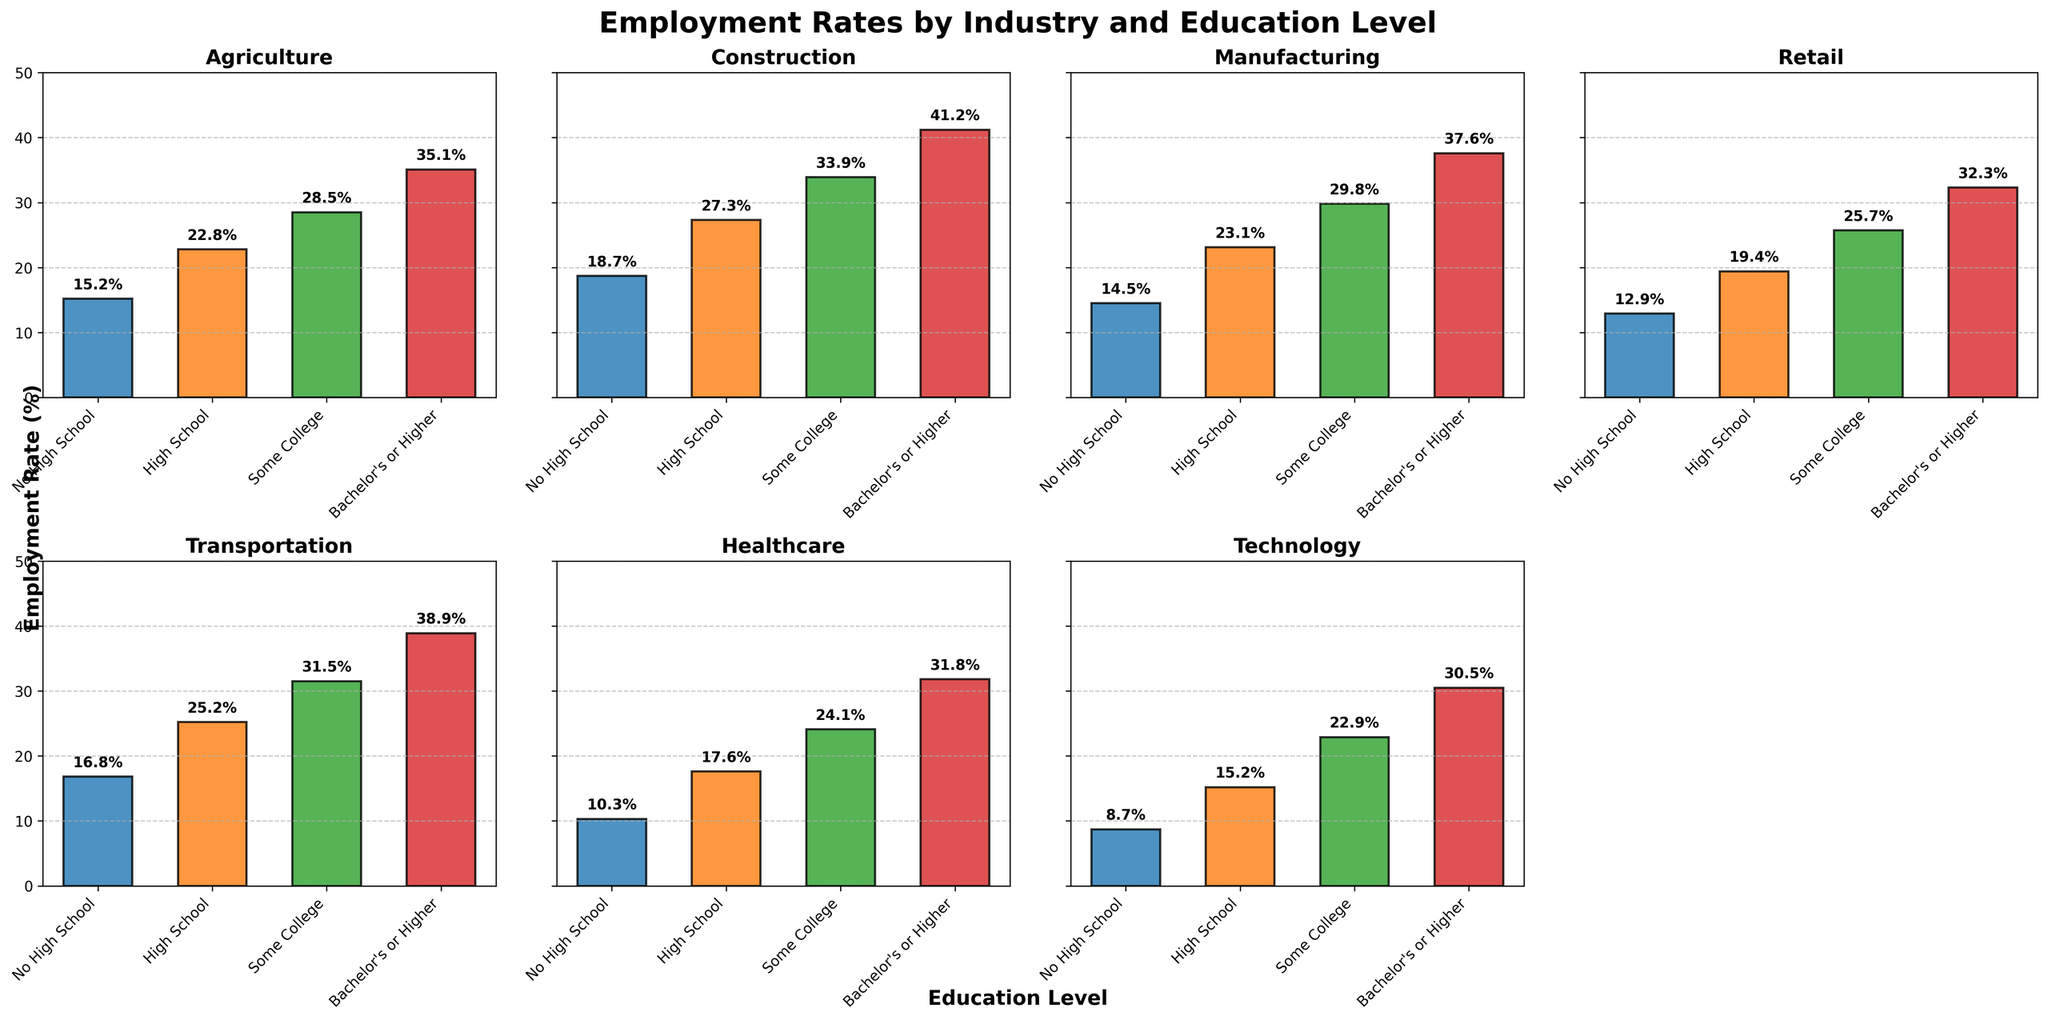Which industry has the highest employment rate for individuals with a Bachelor's or Higher? We review the bars corresponding to the "Bachelor's or Higher" education level across all subplots. The highest bar is in the Hospitality industry.
Answer: Hospitality Compare the employment rates for individuals with Some College education in the Transportation and Retail industries. Which one is higher? We compare the height of the bars corresponding to "Some College" education level in the Transportation and Retail subplots. Transportation's rate is higher at 31.5%, compared to Retail's 25.7%.
Answer: Transportation What is the difference in employment rates between the Technology and Agriculture industries for those with No High School education? We find the bars for "No High School" in both the Technology and Agriculture subplots. The employment rate for Technology is 8.7%, and for Agriculture, it is 15.2%. The difference is 15.2% - 8.7% = 6.5%.
Answer: 6.5% Is there any industry where employment rates increase consistently across all education levels? Reviewing each subplot, we check if each subsequent bar is taller than the previous one. Hospitality industry shows a consistent increase across education levels.
Answer: Yes, Hospitality What is the average employment rate across all industries for individuals with a High School education? We add up the employment rates for "High School" education across all industries: 22.8% (Agriculture) + 27.3% (Construction) + 23.1% (Manufacturing) + 19.4% (Retail) + 25.2% (Transportation) + 17.6% (Healthcare) + 15.2% (Technology) + 28.7% (Hospitality). Then, we divide by the number of industries (8): (22.8 + 27.3 + 23.1 + 19.4 + 25.2 + 17.6 + 15.2 + 28.7) / 8 = 179.3 / 8 ≈ 22.41%.
Answer: 22.41% Which industry exhibits the lowest employment rate for those with No High School education? Evaluating the lowest bar corresponding to "No High School" education across all subplots, Technology has the lowest rate at 8.7%.
Answer: Technology 